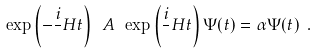Convert formula to latex. <formula><loc_0><loc_0><loc_500><loc_500>\exp \left ( - \frac { i } { } H t \right ) \ A \ \exp \left ( \frac { i } { } H t \right ) \Psi ( t ) = \alpha \Psi ( t ) \ .</formula> 